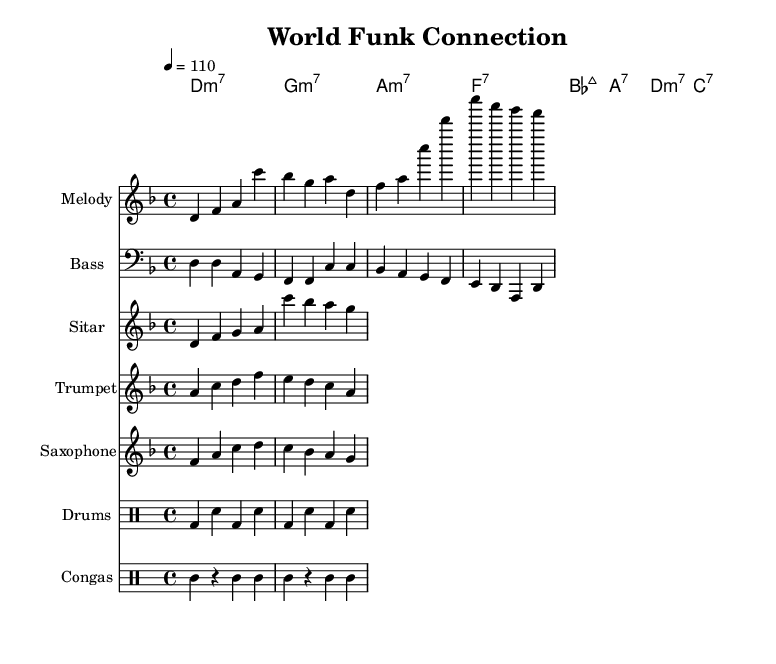What is the key signature of this music? The key signature is indicated at the beginning of the staff for the melody. It shows one flat which corresponds to D minor.
Answer: D minor What is the time signature of the piece? The time signature appears at the start of the staff and it reads 4/4, indicating that there are four beats per measure with a quarter note receiving one beat.
Answer: 4/4 What is the tempo marking for the piece? The tempo marking indicates the speed of the music and is shown above the staff as "4 = 110," suggesting that there are 110 beats per minute.
Answer: 110 How many measures are in the melody? By counting the groups of notes divided by the bar lines in the melody, we see there are 8 measures in total.
Answer: 8 What instruments are included in this score? The instruments are listed at the beginning of each staff, which include Melody, Bass, Sitar, Trumpet, Saxophone, Drums, and Congas.
Answer: Melody, Bass, Sitar, Trumpet, Saxophone, Drums, Congas What is the primary genre style of this piece? The title at the top indicates it is called "World Funk Connection", reflecting the global fusion funk genre that blends international rhythms with classic funk grooves.
Answer: Funk 